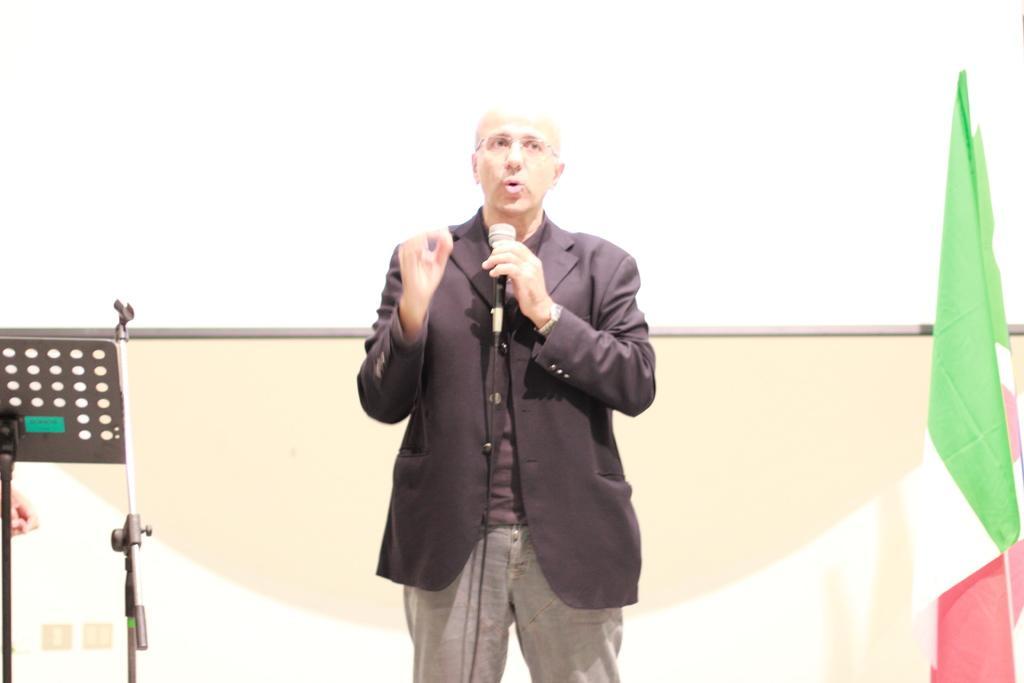In one or two sentences, can you explain what this image depicts? A man is talking on mic behind him there is a fag and screen. 